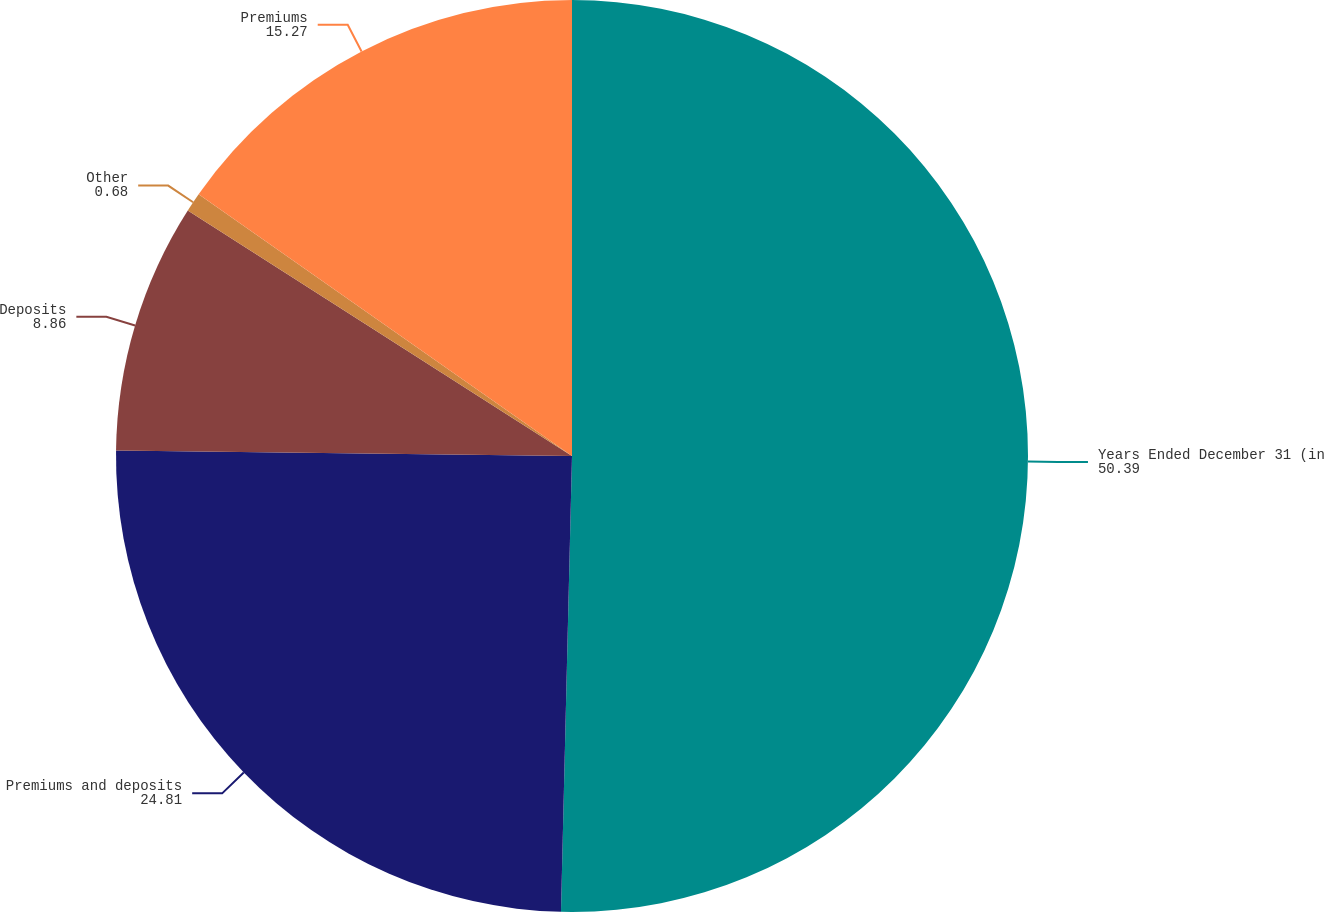Convert chart. <chart><loc_0><loc_0><loc_500><loc_500><pie_chart><fcel>Years Ended December 31 (in<fcel>Premiums and deposits<fcel>Deposits<fcel>Other<fcel>Premiums<nl><fcel>50.39%<fcel>24.81%<fcel>8.86%<fcel>0.68%<fcel>15.27%<nl></chart> 